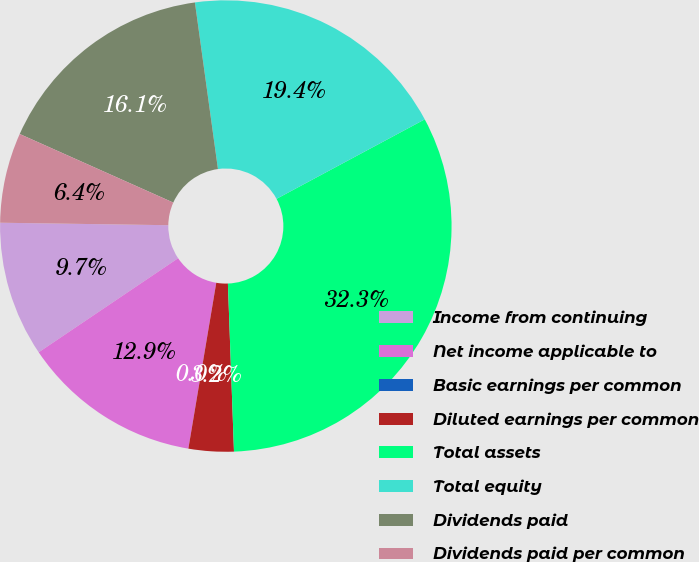Convert chart to OTSL. <chart><loc_0><loc_0><loc_500><loc_500><pie_chart><fcel>Income from continuing<fcel>Net income applicable to<fcel>Basic earnings per common<fcel>Diluted earnings per common<fcel>Total assets<fcel>Total equity<fcel>Dividends paid<fcel>Dividends paid per common<nl><fcel>9.68%<fcel>12.9%<fcel>0.0%<fcel>3.23%<fcel>32.26%<fcel>19.35%<fcel>16.13%<fcel>6.45%<nl></chart> 